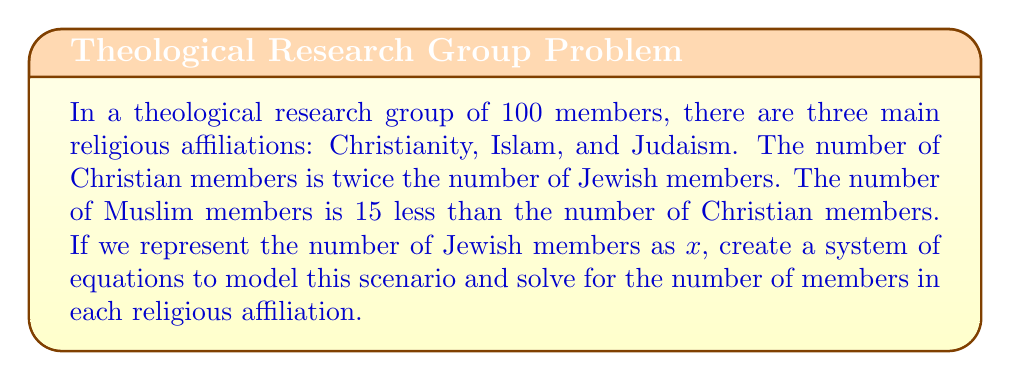Can you solve this math problem? Let's approach this step-by-step:

1) Define variables:
   Let x = number of Jewish members
   Let y = number of Christian members
   Let z = number of Muslim members

2) Set up equations based on the given information:
   Equation 1: Total members
   $$ x + y + z = 100 $$
   
   Equation 2: Christian members are twice Jewish members
   $$ y = 2x $$
   
   Equation 3: Muslim members are 15 less than Christian members
   $$ z = y - 15 $$

3) Substitute Equation 2 into Equation 1:
   $$ x + 2x + z = 100 $$
   $$ 3x + z = 100 $$

4) Substitute Equation 3 into the result from step 3:
   $$ 3x + (2x - 15) = 100 $$
   $$ 3x + 2x - 15 = 100 $$
   $$ 5x - 15 = 100 $$
   $$ 5x = 115 $$
   $$ x = 23 $$

5) Now that we know x, we can solve for y and z:
   $$ y = 2x = 2(23) = 46 $$
   $$ z = y - 15 = 46 - 15 = 31 $$

Therefore, there are 23 Jewish members, 46 Christian members, and 31 Muslim members.
Answer: 23 Jewish, 46 Christian, 31 Muslim members 